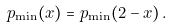<formula> <loc_0><loc_0><loc_500><loc_500>p _ { \min } ( x ) = p _ { \min } ( 2 - x ) \, .</formula> 